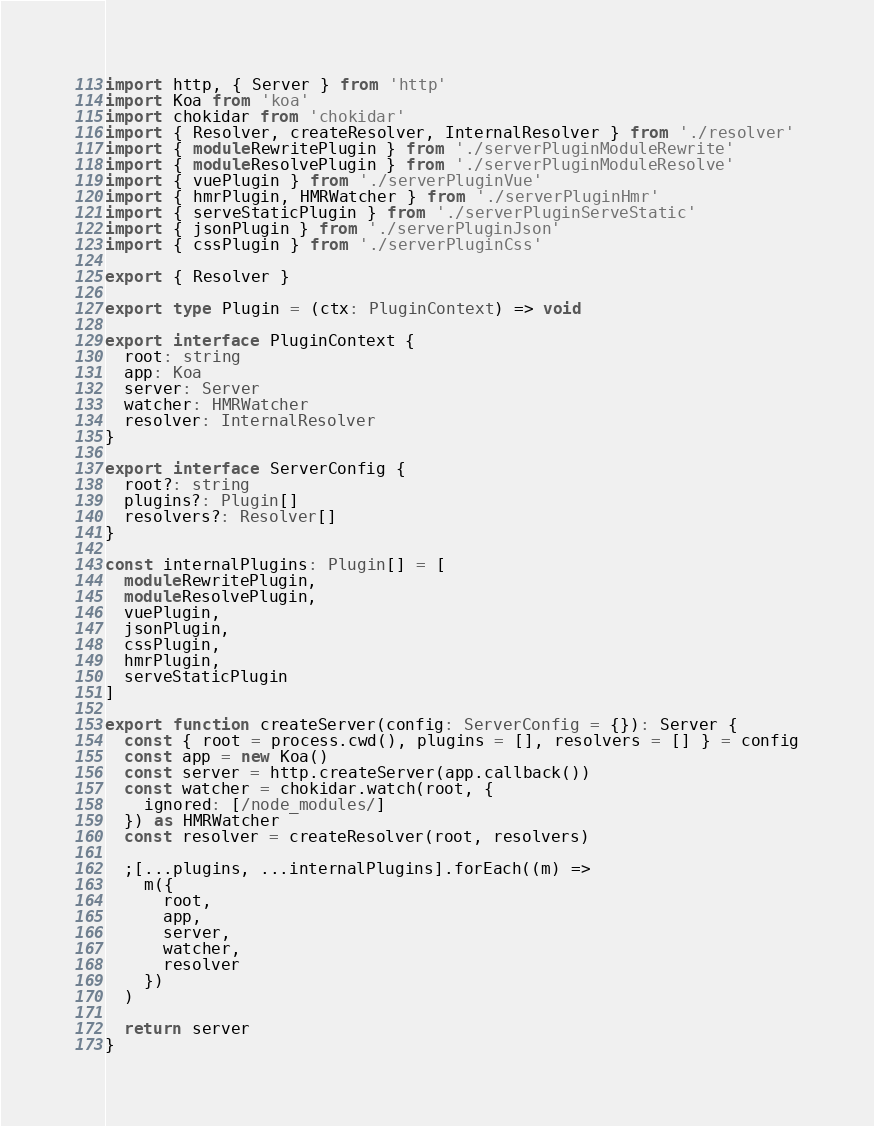<code> <loc_0><loc_0><loc_500><loc_500><_TypeScript_>import http, { Server } from 'http'
import Koa from 'koa'
import chokidar from 'chokidar'
import { Resolver, createResolver, InternalResolver } from './resolver'
import { moduleRewritePlugin } from './serverPluginModuleRewrite'
import { moduleResolvePlugin } from './serverPluginModuleResolve'
import { vuePlugin } from './serverPluginVue'
import { hmrPlugin, HMRWatcher } from './serverPluginHmr'
import { serveStaticPlugin } from './serverPluginServeStatic'
import { jsonPlugin } from './serverPluginJson'
import { cssPlugin } from './serverPluginCss'

export { Resolver }

export type Plugin = (ctx: PluginContext) => void

export interface PluginContext {
  root: string
  app: Koa
  server: Server
  watcher: HMRWatcher
  resolver: InternalResolver
}

export interface ServerConfig {
  root?: string
  plugins?: Plugin[]
  resolvers?: Resolver[]
}

const internalPlugins: Plugin[] = [
  moduleRewritePlugin,
  moduleResolvePlugin,
  vuePlugin,
  jsonPlugin,
  cssPlugin,
  hmrPlugin,
  serveStaticPlugin
]

export function createServer(config: ServerConfig = {}): Server {
  const { root = process.cwd(), plugins = [], resolvers = [] } = config
  const app = new Koa()
  const server = http.createServer(app.callback())
  const watcher = chokidar.watch(root, {
    ignored: [/node_modules/]
  }) as HMRWatcher
  const resolver = createResolver(root, resolvers)

  ;[...plugins, ...internalPlugins].forEach((m) =>
    m({
      root,
      app,
      server,
      watcher,
      resolver
    })
  )

  return server
}
</code> 